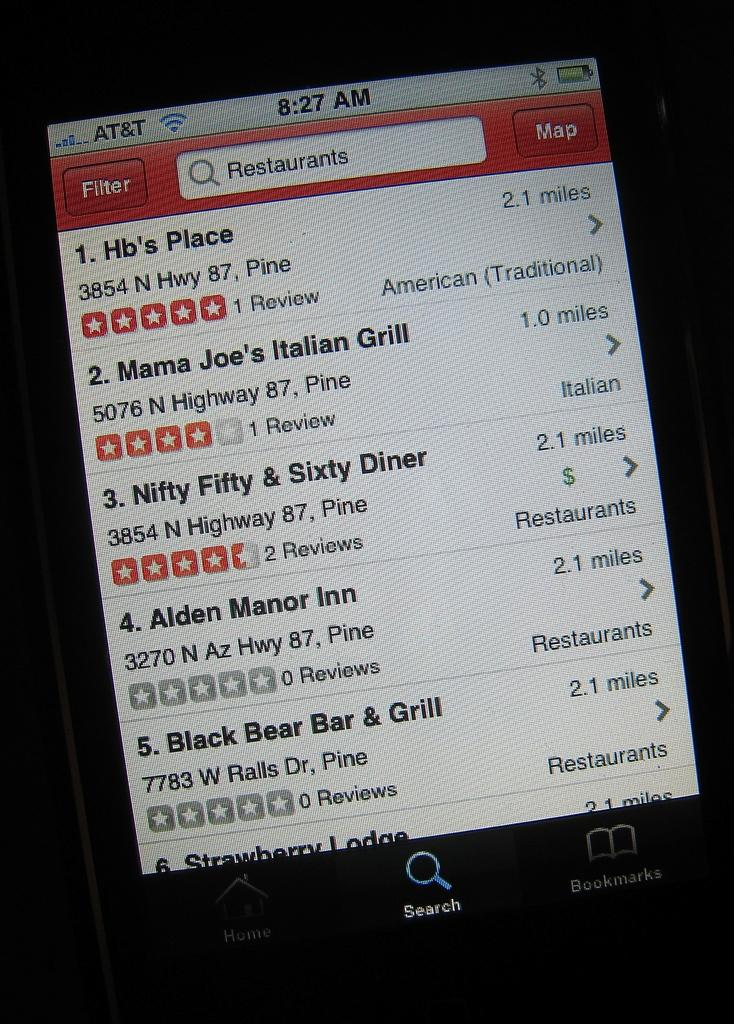Provide a one-sentence caption for the provided image. A phone screen shows that someone searched for restaurants and the results include Hb's Place and Mama Joe's Italian Diner. 